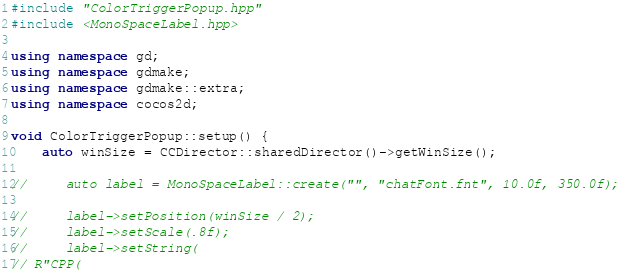<code> <loc_0><loc_0><loc_500><loc_500><_C++_>#include "ColorTriggerPopup.hpp"
#include <MonoSpaceLabel.hpp>

using namespace gd;
using namespace gdmake;
using namespace gdmake::extra;
using namespace cocos2d;

void ColorTriggerPopup::setup() {
    auto winSize = CCDirector::sharedDirector()->getWinSize();

//     auto label = MonoSpaceLabel::create("", "chatFont.fnt", 10.0f, 350.0f);

//     label->setPosition(winSize / 2);
//     label->setScale(.8f);
//     label->setString(
// R"CPP(</code> 